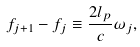Convert formula to latex. <formula><loc_0><loc_0><loc_500><loc_500>f _ { j + 1 } - f _ { j } \equiv \frac { 2 l _ { p } } c \omega _ { j } ,</formula> 